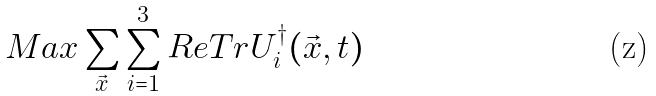Convert formula to latex. <formula><loc_0><loc_0><loc_500><loc_500>M a x \sum _ { \vec { x } } \sum _ { i = 1 } ^ { 3 } R e T r U _ { i } ^ { \dagger } ( \vec { x } , t )</formula> 